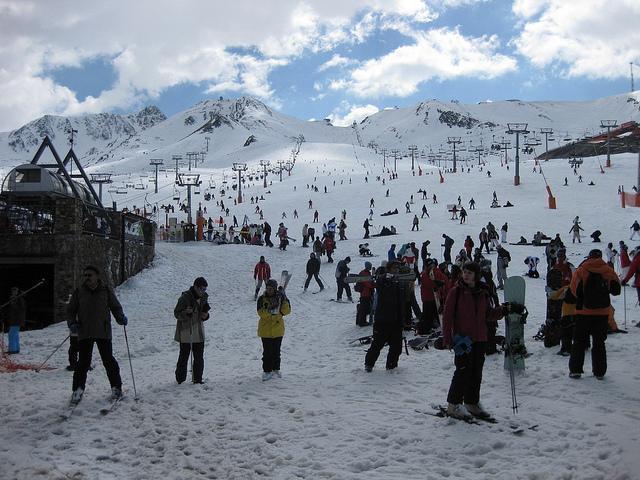How many people are there?
Give a very brief answer. 7. How many white cats are there in the image?
Give a very brief answer. 0. 